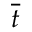Convert formula to latex. <formula><loc_0><loc_0><loc_500><loc_500>\overline { t }</formula> 